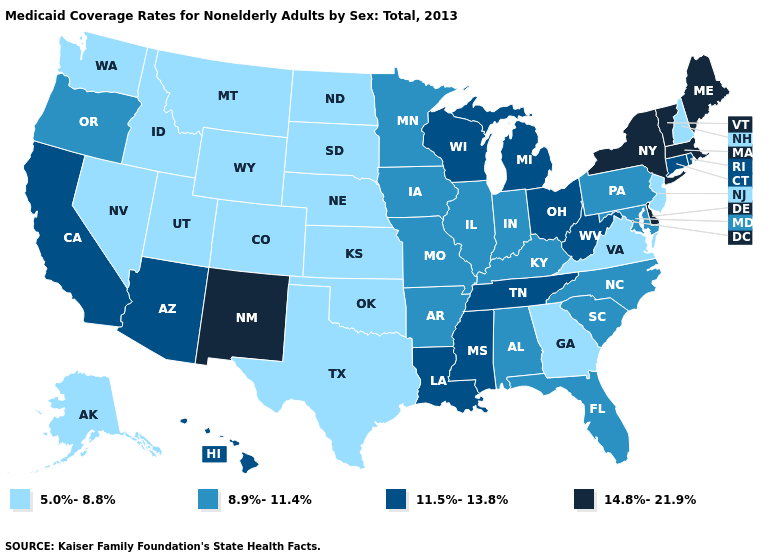What is the value of Louisiana?
Quick response, please. 11.5%-13.8%. Which states hav the highest value in the MidWest?
Keep it brief. Michigan, Ohio, Wisconsin. Name the states that have a value in the range 11.5%-13.8%?
Quick response, please. Arizona, California, Connecticut, Hawaii, Louisiana, Michigan, Mississippi, Ohio, Rhode Island, Tennessee, West Virginia, Wisconsin. Name the states that have a value in the range 5.0%-8.8%?
Concise answer only. Alaska, Colorado, Georgia, Idaho, Kansas, Montana, Nebraska, Nevada, New Hampshire, New Jersey, North Dakota, Oklahoma, South Dakota, Texas, Utah, Virginia, Washington, Wyoming. Is the legend a continuous bar?
Give a very brief answer. No. What is the highest value in the MidWest ?
Give a very brief answer. 11.5%-13.8%. Does Kansas have the lowest value in the MidWest?
Short answer required. Yes. What is the value of Maryland?
Short answer required. 8.9%-11.4%. Does Michigan have the same value as New York?
Quick response, please. No. Name the states that have a value in the range 5.0%-8.8%?
Concise answer only. Alaska, Colorado, Georgia, Idaho, Kansas, Montana, Nebraska, Nevada, New Hampshire, New Jersey, North Dakota, Oklahoma, South Dakota, Texas, Utah, Virginia, Washington, Wyoming. Which states have the lowest value in the USA?
Answer briefly. Alaska, Colorado, Georgia, Idaho, Kansas, Montana, Nebraska, Nevada, New Hampshire, New Jersey, North Dakota, Oklahoma, South Dakota, Texas, Utah, Virginia, Washington, Wyoming. What is the value of Massachusetts?
Concise answer only. 14.8%-21.9%. Among the states that border New Jersey , which have the lowest value?
Answer briefly. Pennsylvania. What is the lowest value in the USA?
Concise answer only. 5.0%-8.8%. Name the states that have a value in the range 11.5%-13.8%?
Quick response, please. Arizona, California, Connecticut, Hawaii, Louisiana, Michigan, Mississippi, Ohio, Rhode Island, Tennessee, West Virginia, Wisconsin. 